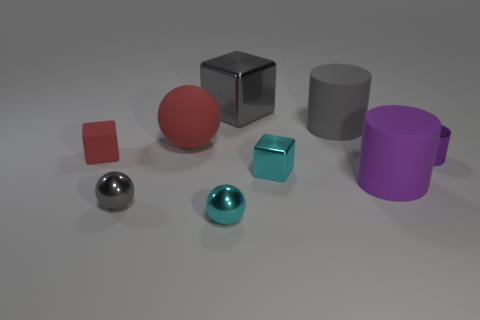Add 1 red shiny balls. How many objects exist? 10 Subtract all cubes. How many objects are left? 6 Subtract all red objects. Subtract all rubber cylinders. How many objects are left? 5 Add 4 cyan metal spheres. How many cyan metal spheres are left? 5 Add 3 large gray rubber cylinders. How many large gray rubber cylinders exist? 4 Subtract 0 green balls. How many objects are left? 9 